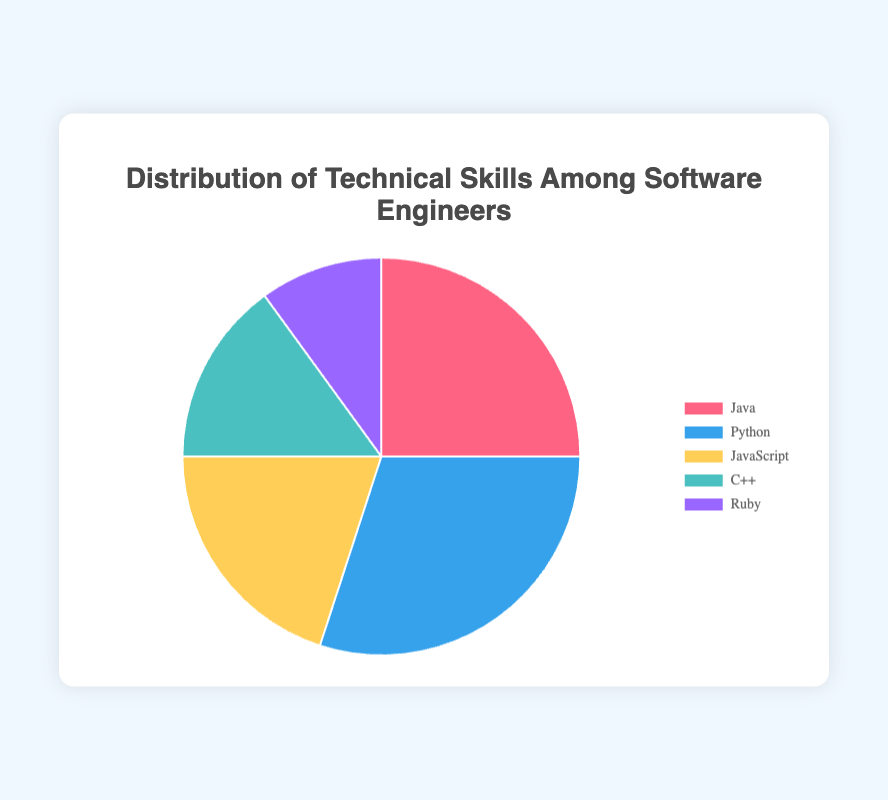How many more software engineers know Python compared to Ruby? Python has a percentage of 30% and Ruby has a percentage of 10%. The difference is 30% - 10% = 20%.
Answer: 20% Which technical skill has the largest representation among software engineers? Python has the largest percentage at 30%.
Answer: Python What is the combined percentage of software engineers proficient in Java and C++? Java has 25% and C++ has 15%. The combined percentage is 25% + 15% = 40%.
Answer: 40% Which technical skill is represented by the orange section in the pie chart? The orange section represents JavaScript, as indicated by the color coding.
Answer: JavaScript How does the percentage of JavaScript developers compare to C++ developers? JavaScript has a percentage of 20% whereas C++ has 15%. JavaScript developers make up 5% more than C++ developers.
Answer: 5% What is the least represented technical skill among software engineers? Ruby, which has the lowest percentage at 10%.
Answer: Ruby What is the total percentage of software engineers proficient in Java, Python, and JavaScript combined? Java has 25%, Python has 30%, and JavaScript has 20%. Their combined percentage is 25% + 30% + 20% = 75%.
Answer: 75% Which skill has a smaller representation than Java but larger than Ruby? C++, which has 15%, falls between Java's 25% and Ruby's 10%.
Answer: C++ Is the percentage of Python engineers greater than the combined percentage of Ruby and C++ engineers? Python has 30%, Ruby has 10%, and C++ has 15%. The combined percentage of Ruby and C++ is 10% + 15% = 25%, which is less than Python's 30%.
Answer: Yes 